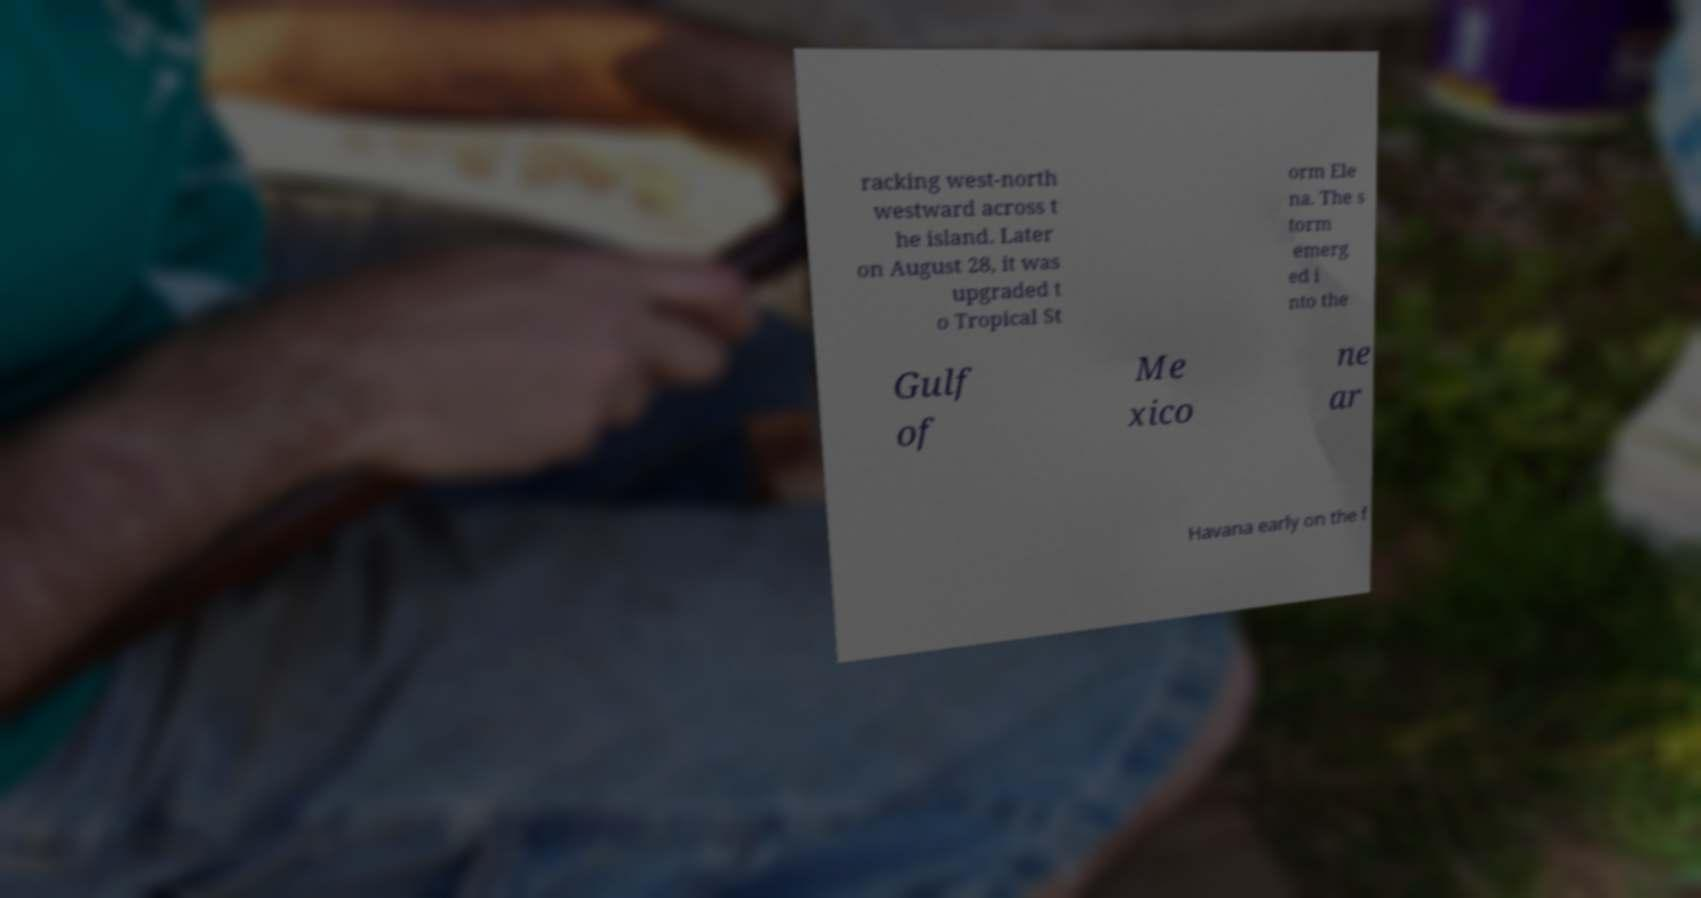Can you accurately transcribe the text from the provided image for me? racking west-north westward across t he island. Later on August 28, it was upgraded t o Tropical St orm Ele na. The s torm emerg ed i nto the Gulf of Me xico ne ar Havana early on the f 